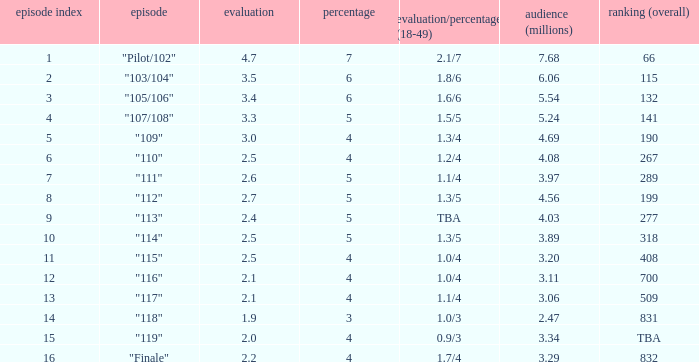WHAT IS THE RATING THAT HAD A SHARE SMALLER THAN 4, AND 2.47 MILLION VIEWERS? 0.0. 